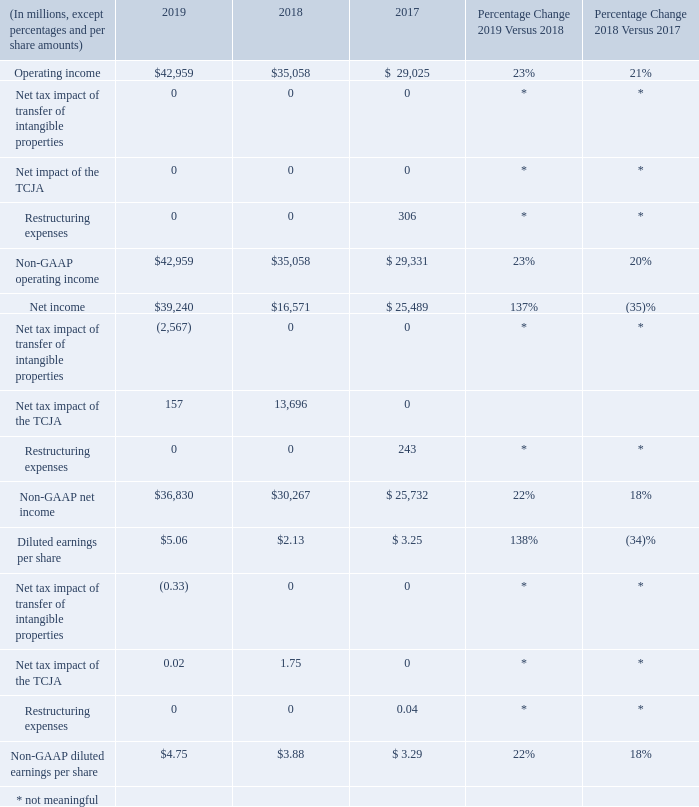NON-GAAP FINANCIAL MEASURES
Non-GAAP operating income, net income, and diluted EPS are non-GAAP financial measures which exclude the net tax impact of transfer of intangible properties, the net tax impact of the TCJA, and restructuring expenses. We believe these non-GAAP measures aid investors by providing additional insight into our operational performance and help clarify trends affecting our business. For comparability of reporting, management considers non-GAAP measures in conjunction with GAAP financial results in evaluating business performance. These non-GAAP financial measures presented should not be considered a substitute for, or superior to, the measures of financial performance prepared in accordance with GAAP.
The following table reconciles our financial results reported in accordance with GAAP to non-GAAP financial results:
* Not meaningful.
How do these non-GAAP measures aid investors? We believe these non-gaap measures aid investors by providing additional insight into our operational performance and help clarify trends affecting our business. Why does management consider non-GAAP measures in conjunction with GAAP financial results? Management considers non-gaap measures in conjunction with gaap financial results in evaluating business performance. Which non-GAAP measures exclude the net tax impact of transfer of intangible properties, the net tax impact of the TCJA and restructuring expenses? Non-gaap operating income, net income, and diluted eps are non-gaap financial measures which exclude the net tax impact of transfer of intangible properties, the net tax impact of the tcja, and restructuring expenses. What was the average operating income for the 3 year period from 2017 to 2019?
Answer scale should be: million. (42,959 + 35,058+29,025)/(2019-2017+1)
Answer: 35680.67. What is the average non-GAAP net income for the 3 year period from 2017 to 2019?
Answer scale should be: million. (36,830+30,267+25,732)/(2019-2017+1)
Answer: 30943. What is the percentage change in operating income from 2017 to 2019?
Answer scale should be: percent. (42,959-29,025)/29,025
Answer: 48.01. 